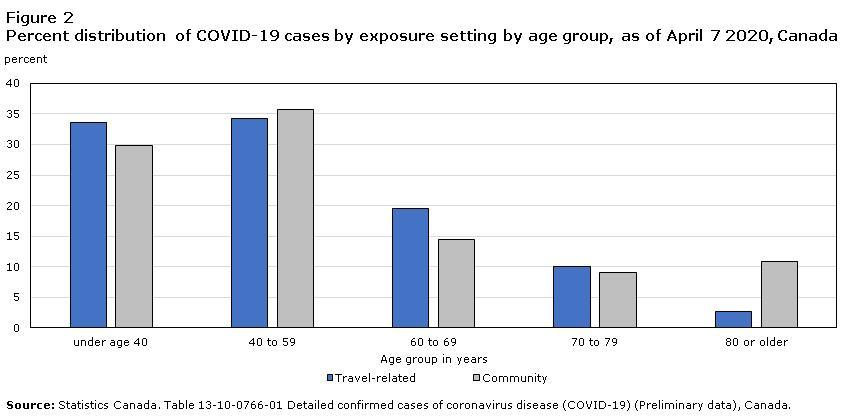In which age group people of Canada, the percent distribution of COVID-19 cases due to travel-related exposures is less than 5% as of April 7, 2020?
Answer the question with a short phrase. 80 or older What is the percent distribution of COVID-19 cases in people aged under 40 years due to community transmission as of April 7, 2020 in Canada? 30 In which age group people of Canada, the percent distribution of COVID-19 cases by community transmission is greater than 35% as of April 7, 2020? 40 to 59 What is the percent distribution of COVID-19 cases in people aged between 70-79 years due to travel-related exposure as of April 7, 2020 in Canada? 10 